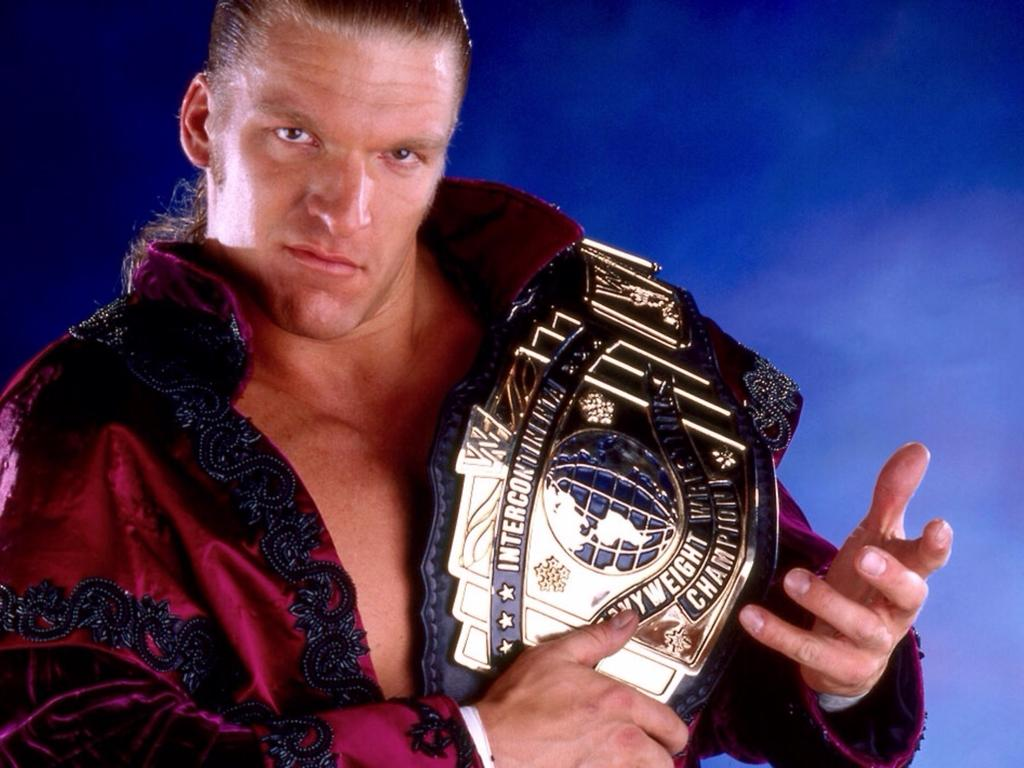<image>
Write a terse but informative summary of the picture. A professional wrestler is holding the intercontinental heavyweight belt. 